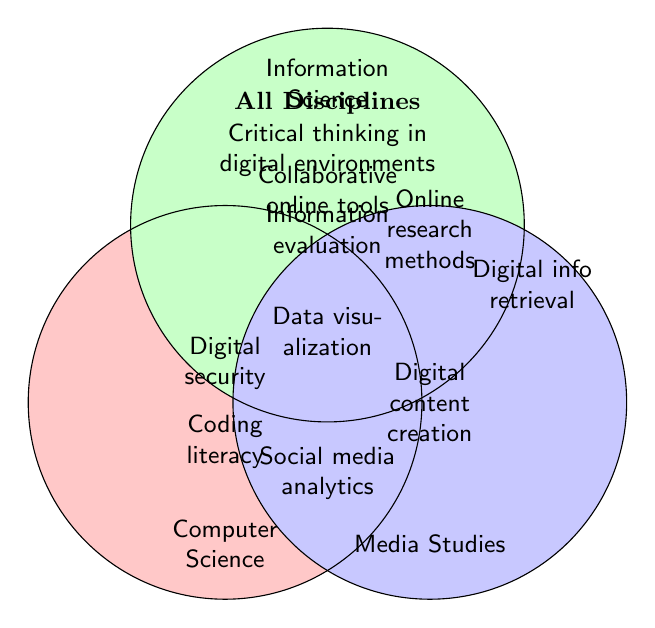Which disciplines share the skill "Data visualization"? "Data visualization" is located at the intersect of Computer Science and Information Science circles. Therefore, both disciplines share this skill.
Answer: Computer Science, Information Science What skills are shared by all disciplines? The intersection labeled "All Disciplines" lists skills shared by all disciplines, such as "Critical thinking in digital environments", "Collaborative online tools", and "Information evaluation".
Answer: Critical thinking in digital environments, Collaborative online tools, Information evaluation Which skills are unique to Media Studies? The areas specific to Media Studies list "Digital content creation" and "Social media analytics" only within the Media Studies circle.
Answer: Digital content creation, Social media analytics How many disciplines share the skill "Online research methods"? "Online research methods" appears in the intersecting section of Information Science and Media Studies circles, indicating these two disciplines share this skill.
Answer: 2 Which skill is at the intersection of Computer Science and no other discipline? Skills within the Computer Science circle but not overlapping with any other circles include "Coding literacy" and "Digital security".
Answer: Coding literacy, Digital security Which skills are shared by Computer Science and Information Science, but not by Media Studies? "Data visualization" is in the intersecting area of Computer Science and Information Science but not within Media Studies.
Answer: Data visualization What skills are shared by Information Science and Media Studies? The intersection of Information Science and Media Studies circles lists "Online research methods".
Answer: Online research methods Is "Digital information retrieval" shared by any other disciplines? "Digital information retrieval" is within the Information Science circle only and does not intersect with any other circles.
Answer: No Which discipline has the least shared skills? Media Studies has the least shared skills, with only "Online research methods" overlapping with another discipline, Information Science.
Answer: Media Studies 